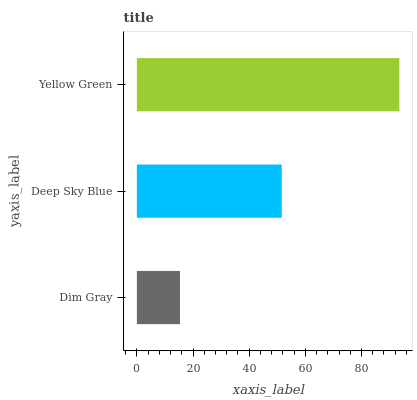Is Dim Gray the minimum?
Answer yes or no. Yes. Is Yellow Green the maximum?
Answer yes or no. Yes. Is Deep Sky Blue the minimum?
Answer yes or no. No. Is Deep Sky Blue the maximum?
Answer yes or no. No. Is Deep Sky Blue greater than Dim Gray?
Answer yes or no. Yes. Is Dim Gray less than Deep Sky Blue?
Answer yes or no. Yes. Is Dim Gray greater than Deep Sky Blue?
Answer yes or no. No. Is Deep Sky Blue less than Dim Gray?
Answer yes or no. No. Is Deep Sky Blue the high median?
Answer yes or no. Yes. Is Deep Sky Blue the low median?
Answer yes or no. Yes. Is Yellow Green the high median?
Answer yes or no. No. Is Yellow Green the low median?
Answer yes or no. No. 